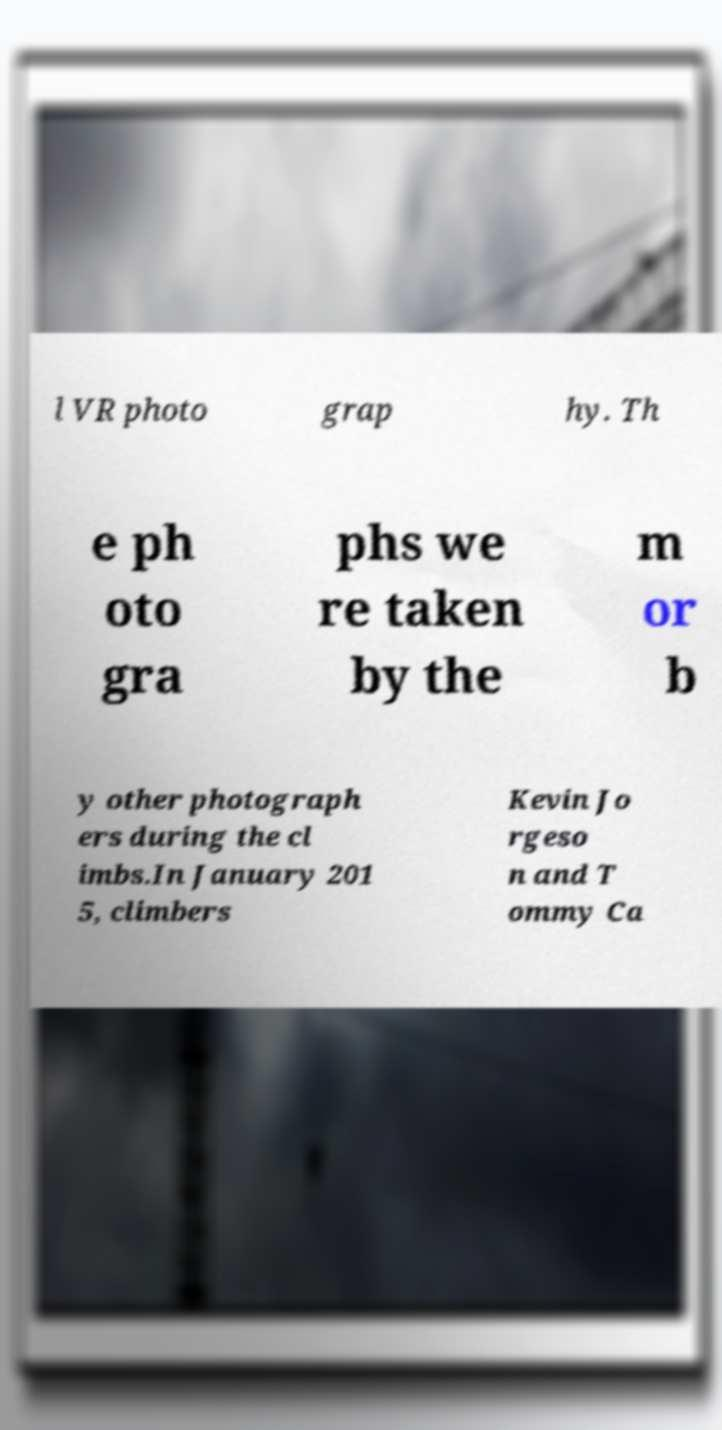There's text embedded in this image that I need extracted. Can you transcribe it verbatim? l VR photo grap hy. Th e ph oto gra phs we re taken by the m or b y other photograph ers during the cl imbs.In January 201 5, climbers Kevin Jo rgeso n and T ommy Ca 